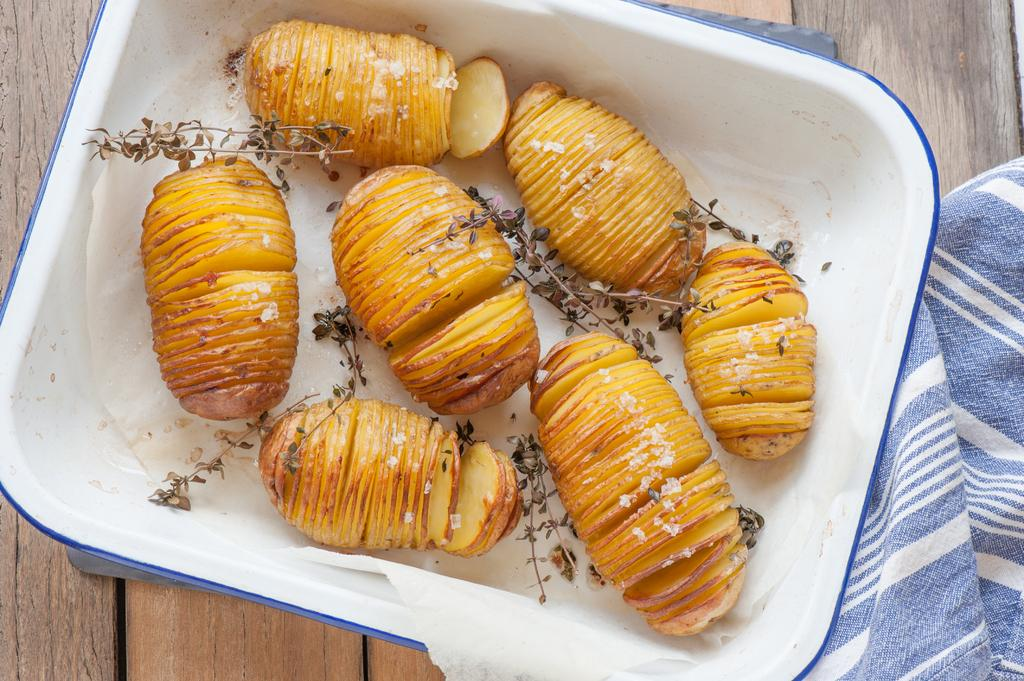What is on the plate in the image? There are potato slices and leaves on the plate in the image. What type of material is the cloth made of? The cloth in the image is not specified, but it is present. What can be seen on the wooden surface in the image? The wooden surface is present in the image, but no specific details about what is on it are provided. What type of ink is being used by the horses in the image? There are no horses or ink present in the image. How many wrenches can be seen on the wooden surface in the image? There are no wrenches present in the image. 